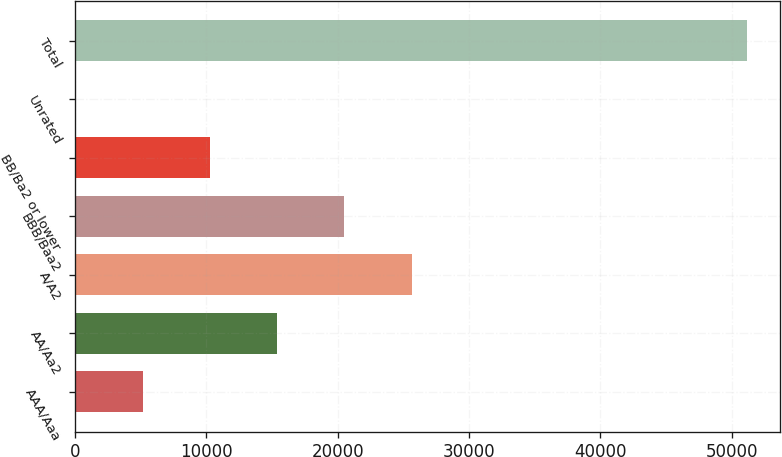Convert chart to OTSL. <chart><loc_0><loc_0><loc_500><loc_500><bar_chart><fcel>AAA/Aaa<fcel>AA/Aa2<fcel>A/A2<fcel>BBB/Baa2<fcel>BB/Ba2 or lower<fcel>Unrated<fcel>Total<nl><fcel>5152.8<fcel>15368.4<fcel>25666<fcel>20476.2<fcel>10260.6<fcel>45<fcel>51123<nl></chart> 